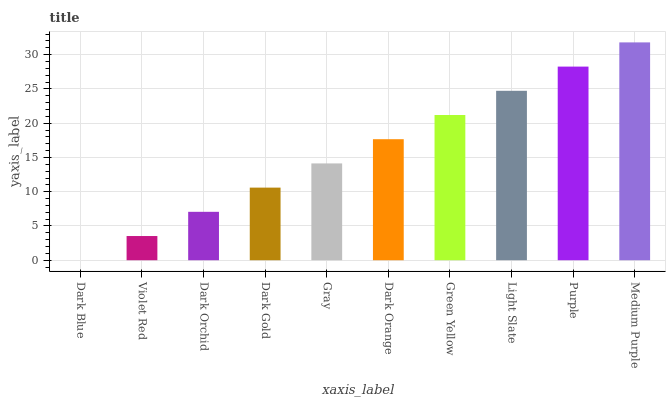Is Violet Red the minimum?
Answer yes or no. No. Is Violet Red the maximum?
Answer yes or no. No. Is Violet Red greater than Dark Blue?
Answer yes or no. Yes. Is Dark Blue less than Violet Red?
Answer yes or no. Yes. Is Dark Blue greater than Violet Red?
Answer yes or no. No. Is Violet Red less than Dark Blue?
Answer yes or no. No. Is Dark Orange the high median?
Answer yes or no. Yes. Is Gray the low median?
Answer yes or no. Yes. Is Violet Red the high median?
Answer yes or no. No. Is Purple the low median?
Answer yes or no. No. 